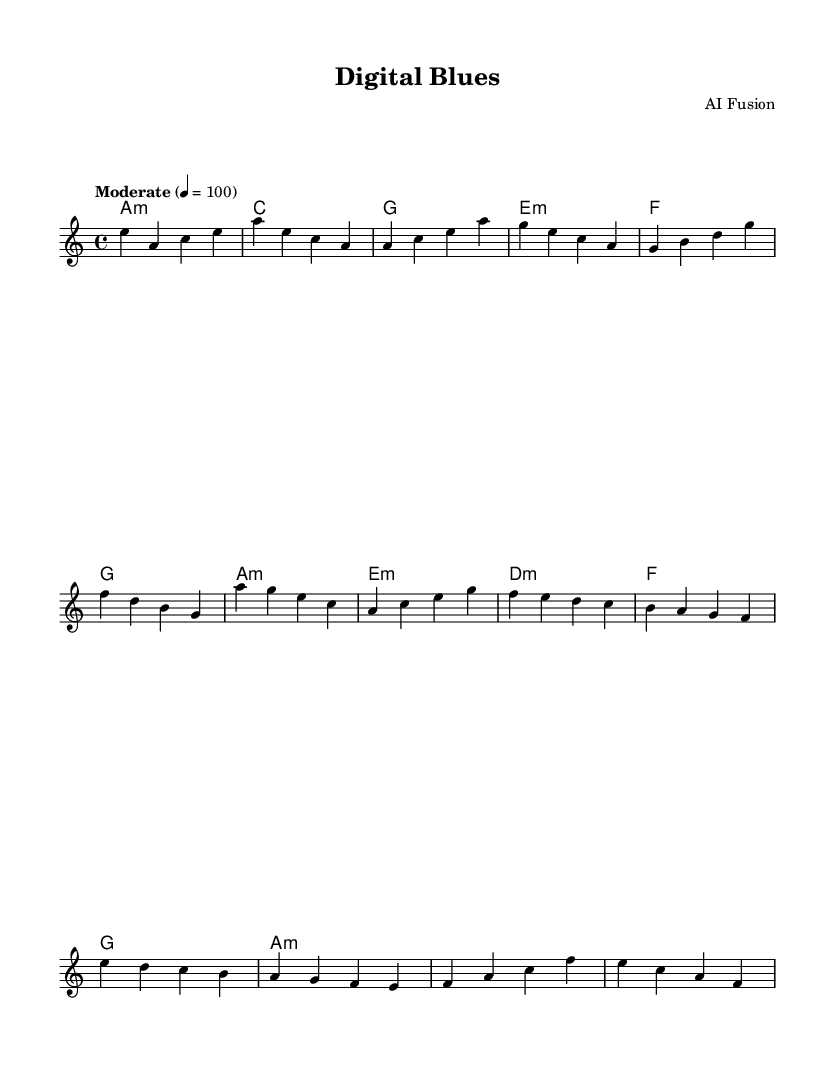What is the key signature of this music? The key signature indicated at the beginning of the sheet music shows one flat, which corresponds to A minor.
Answer: A minor What is the time signature of the music? The time signature is displayed at the start, indicating that there are four beats per measure, which is represented as 4/4.
Answer: 4/4 What is the tempo marking for this piece? The tempo marking is explicitly stated in the sheet music as "Moderate" with a metronome marking of 100 beats per minute, indicating the speed of the piece.
Answer: Moderate 100 What is the name of the piece? The title of the piece is shown at the top of the sheet music as "Digital Blues".
Answer: Digital Blues How many sections does the piece have? The music is divided into three main sections: Verse, Chorus, and Bridge, which can be identified by the structure of the music.
Answer: Three Which chord is played at the beginning of the Verse? The first chord written in the harmonies section for the Verse is A minor, shown as a minor chord in the chord progression.
Answer: A minor What musical genre does this piece belong to? The title and the elements incorporated suggest that it falls under the Blues genre, specifically an urban fusion style that addresses contemporary themes like online identity and privacy.
Answer: Blues 